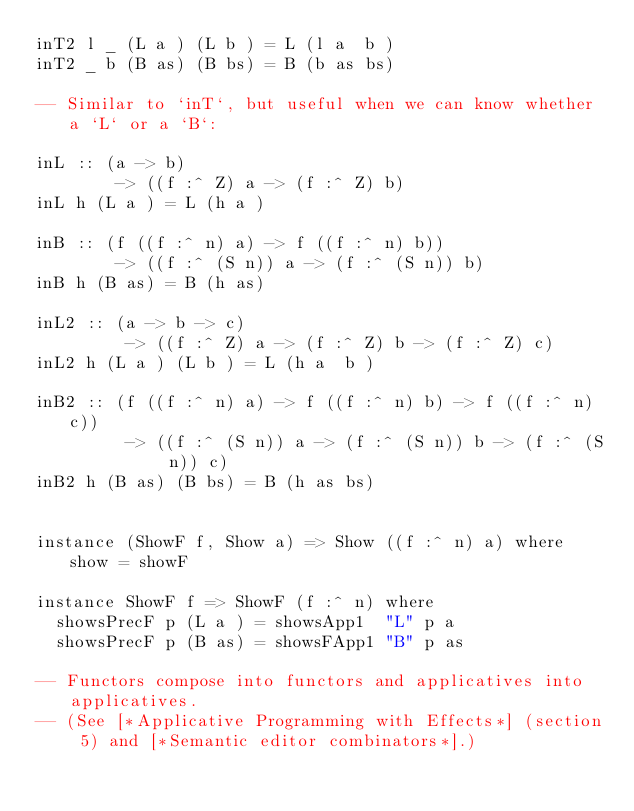<code> <loc_0><loc_0><loc_500><loc_500><_Haskell_>inT2 l _ (L a ) (L b ) = L (l a  b )
inT2 _ b (B as) (B bs) = B (b as bs)

-- Similar to `inT`, but useful when we can know whether a `L` or a `B`:

inL :: (a -> b)
        -> ((f :^ Z) a -> (f :^ Z) b)
inL h (L a ) = L (h a )

inB :: (f ((f :^ n) a) -> f ((f :^ n) b))
        -> ((f :^ (S n)) a -> (f :^ (S n)) b)
inB h (B as) = B (h as)

inL2 :: (a -> b -> c)
         -> ((f :^ Z) a -> (f :^ Z) b -> (f :^ Z) c)
inL2 h (L a ) (L b ) = L (h a  b )

inB2 :: (f ((f :^ n) a) -> f ((f :^ n) b) -> f ((f :^ n) c))
         -> ((f :^ (S n)) a -> (f :^ (S n)) b -> (f :^ (S n)) c)
inB2 h (B as) (B bs) = B (h as bs)


instance (ShowF f, Show a) => Show ((f :^ n) a) where show = showF

instance ShowF f => ShowF (f :^ n) where
  showsPrecF p (L a ) = showsApp1  "L" p a
  showsPrecF p (B as) = showsFApp1 "B" p as

-- Functors compose into functors and applicatives into applicatives.
-- (See [*Applicative Programming with Effects*] (section 5) and [*Semantic editor combinators*].)</code> 